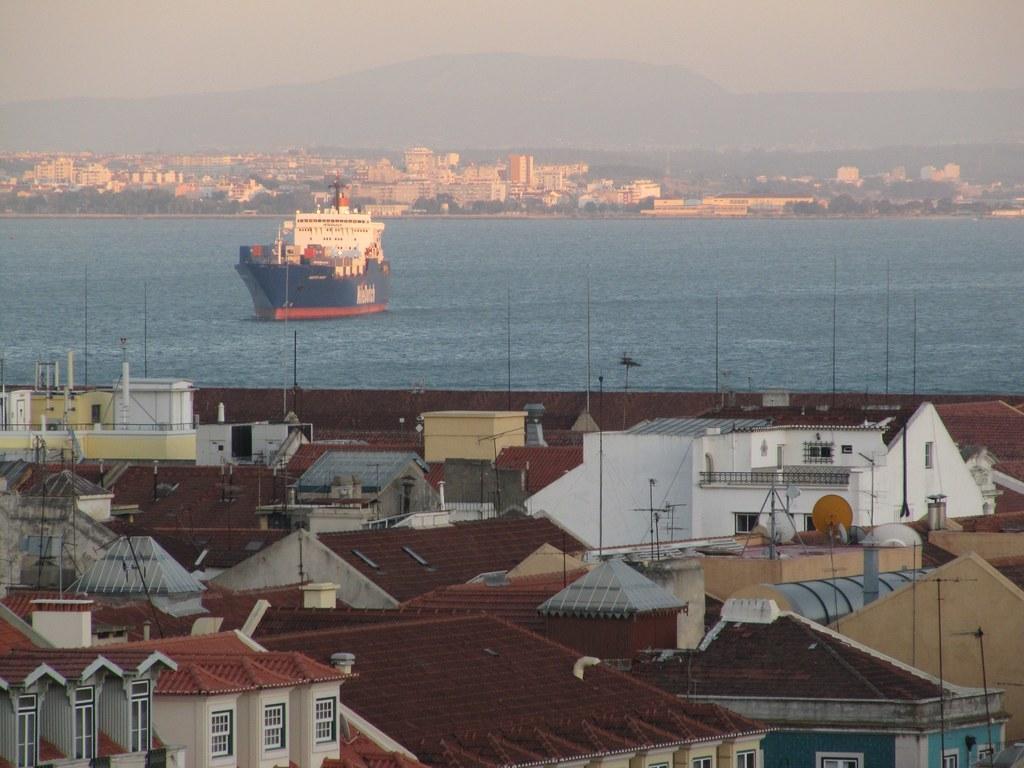How would you summarize this image in a sentence or two? In this picture we can see houses and in the background we can see a boat, water, buildings, mountains, trees and the sky. 